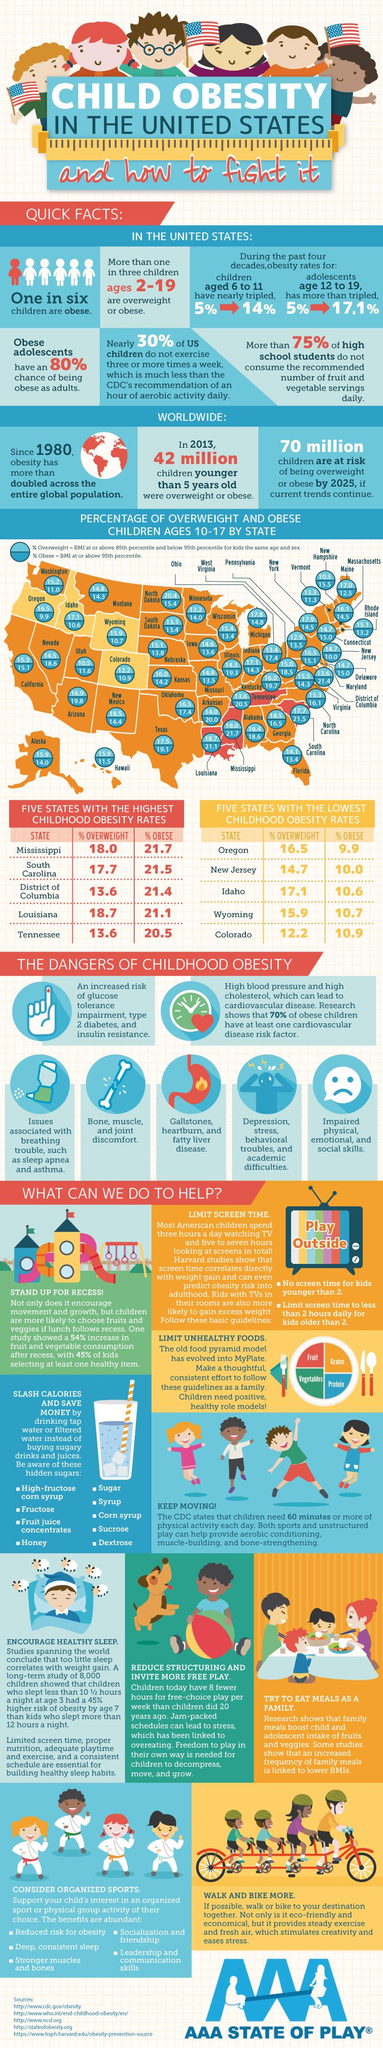Indicate a few pertinent items in this graphic. According to recent statistics, in Virginia, 14.3% of children aged 10-17 are obese. Louisiana has the second highest percentage of overweight children aged 10-17, according to the data. According to statistics, in Minnesota, 14% of children aged 10-17 are obese. New Jersey has the second lowest percentage of obese children aged 10-17 out of all the states in the United States. In the past four decades, there has been a significant increase in obesity rates among adolescents aged 12-19, with a 12.1% increase reported. 